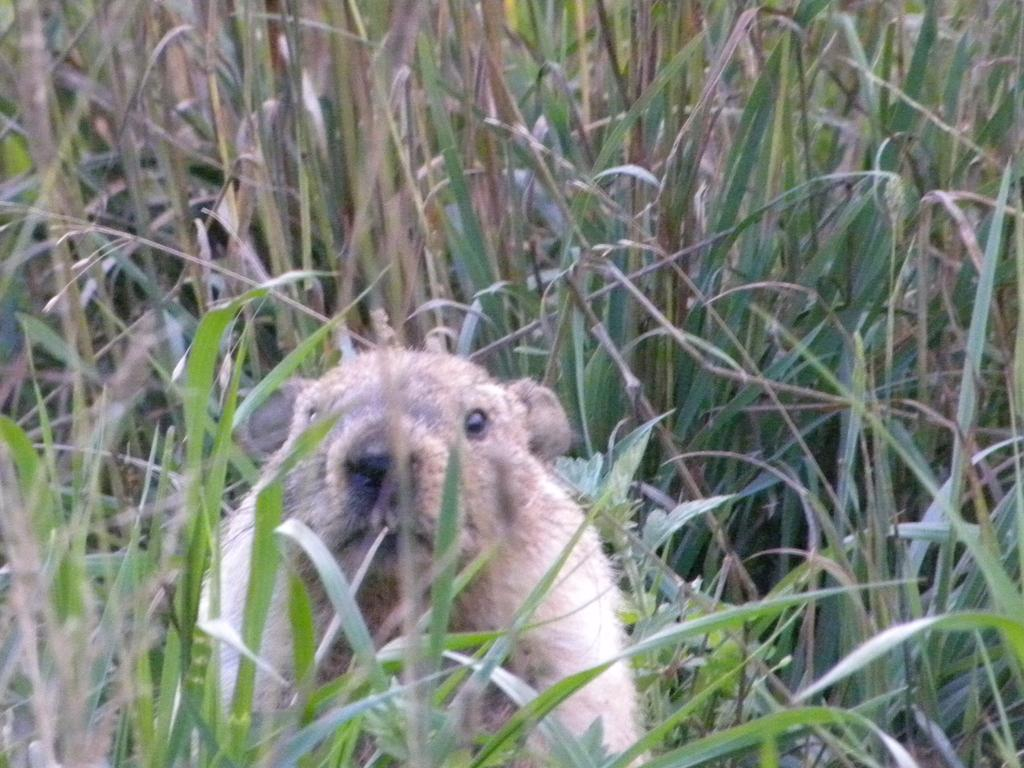What type of living creature is in the image? There is an animal in the image. Can you describe the animal's location in the image? The animal is between the grass. What type of glove is the animal wearing on its feet in the image? There is no glove or indication of footwear on the animal in the image. 